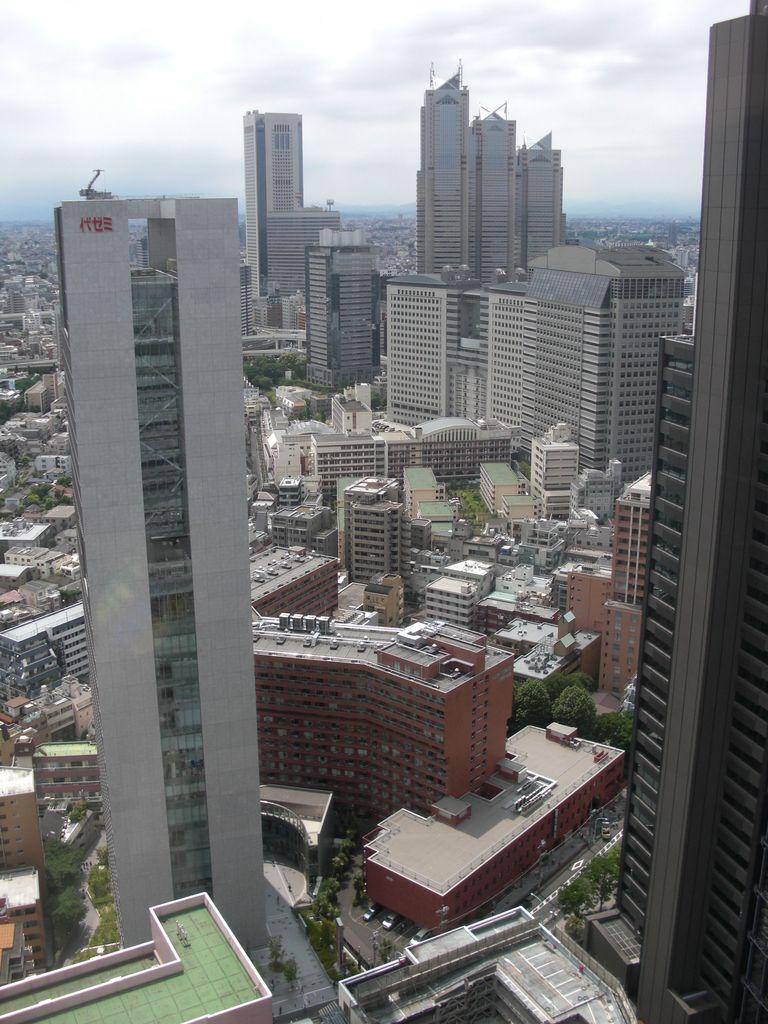In one or two sentences, can you explain what this image depicts? In this image we can see a group of buildings with windows, a group of trees and some poles. At the top of the image we can see the sky. 